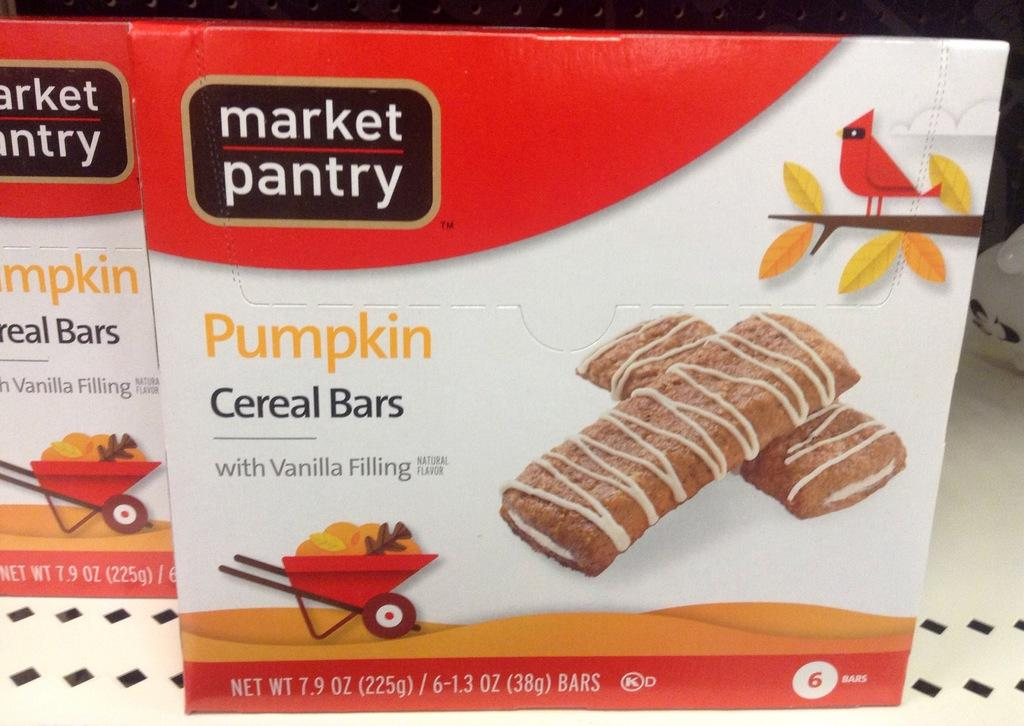What is located on the platform in the image? There are boards on a platform in the image. What can be seen in the background of the image? There are roads visible in the image. What type of vehicles are on the roads? There are carts on the roads. What else is present in the image besides the boards and carts? Food items are present in the image. Can you describe any living creatures in the image? There is a bird on a branch in the image. How many ducks are sitting on the lunchroom table in the image? There are no ducks or lunchroom table present in the image. Are there any bikes visible on the roads in the image? There is no mention of bikes in the provided facts, and therefore we cannot determine if they are present in the image. 